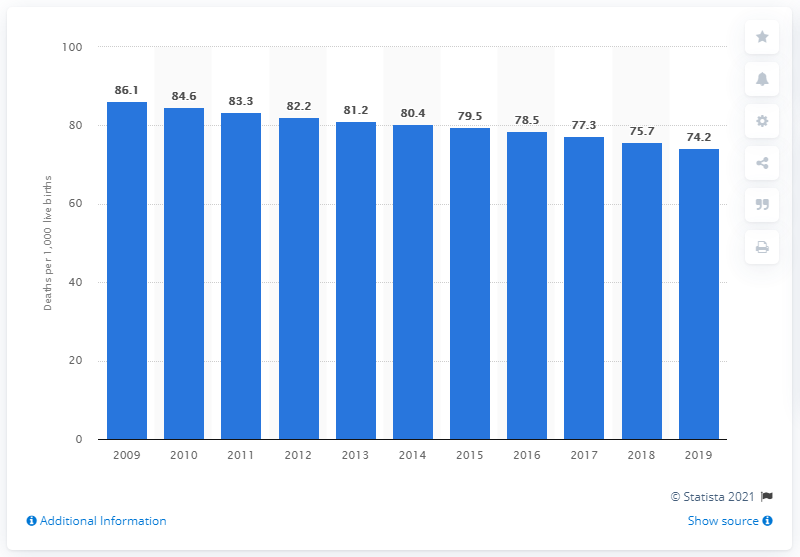Draw attention to some important aspects in this diagram. In 2019, Nigeria's infant mortality rate per 1,000 live births was 74.2. 